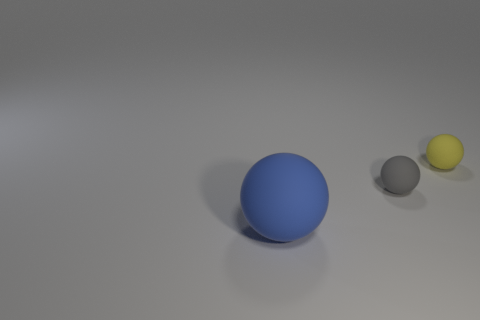Is there a small ball left of the ball behind the tiny gray matte sphere?
Provide a succinct answer. Yes. What color is the other tiny matte thing that is the same shape as the gray thing?
Your answer should be very brief. Yellow. How many things are either tiny rubber objects that are left of the yellow rubber thing or matte things?
Make the answer very short. 3. What is the material of the tiny thing on the left side of the sphere that is to the right of the tiny object that is in front of the tiny yellow matte object?
Offer a terse response. Rubber. Is the number of large matte spheres that are left of the yellow matte ball greater than the number of big balls that are to the left of the blue matte thing?
Your answer should be very brief. Yes. What number of cubes are blue things or small matte objects?
Provide a succinct answer. 0. There is a tiny object that is left of the tiny matte sphere that is behind the small gray matte ball; how many tiny yellow things are on the left side of it?
Your answer should be compact. 0. Is the number of tiny things greater than the number of big yellow blocks?
Keep it short and to the point. Yes. Do the gray rubber sphere and the yellow ball have the same size?
Provide a succinct answer. Yes. What number of things are large spheres or tiny rubber cylinders?
Keep it short and to the point. 1. 